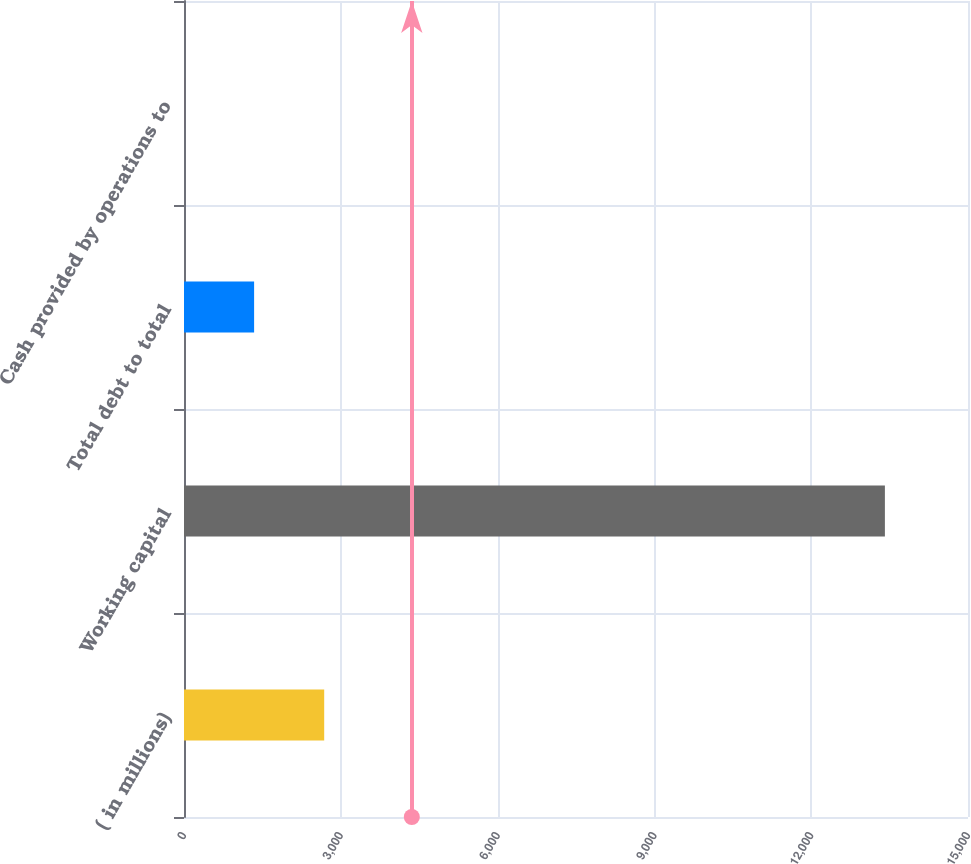<chart> <loc_0><loc_0><loc_500><loc_500><bar_chart><fcel>( in millions)<fcel>Working capital<fcel>Total debt to total<fcel>Cash provided by operations to<nl><fcel>2682.33<fcel>13410<fcel>1341.37<fcel>0.41<nl></chart> 